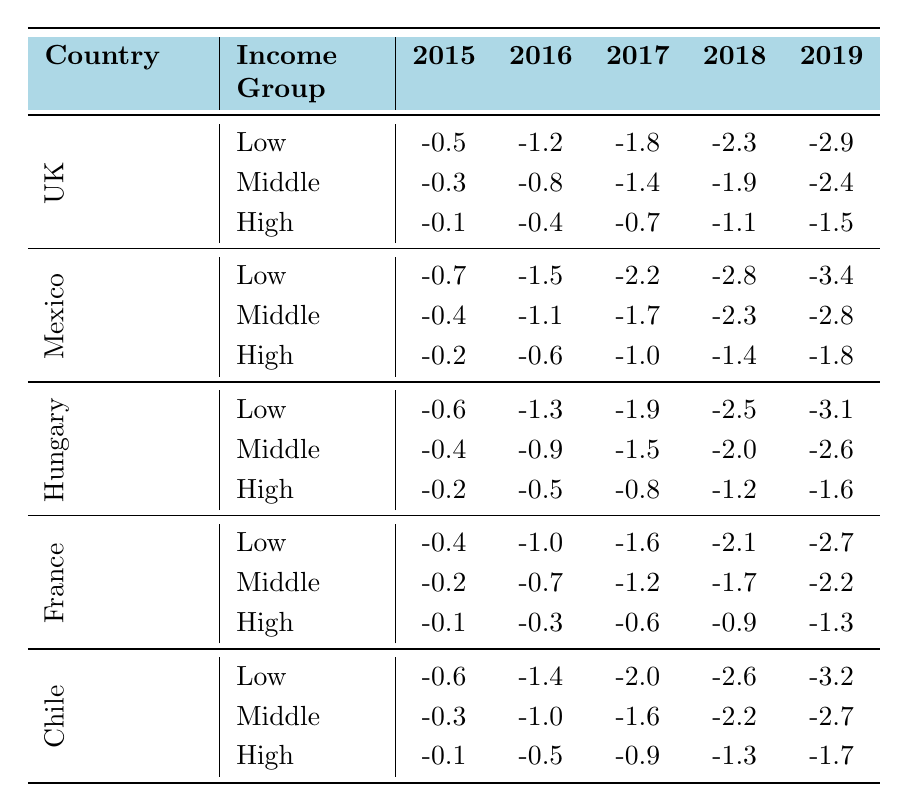What was the obesity rate change in the Low income group in Mexico in 2019? Referring to the table, the value for Mexico in the Low income group for 2019 is -3.4.
Answer: -3.4 Which income group in Hungary experienced the smallest reduction in obesity rates in 2016? In Hungary, the values for 2016 are -1.3 for Low income, -0.9 for Middle income, and -0.5 for High income. The smallest reduction is -0.5 in the High income group.
Answer: High income What is the average obesity rate change for the Middle income group across all countries in 2018? To find the average, we sum the values for the Middle income group in 2018: -1.9 (UK) + -2.3 (Mexico) + -2.0 (Hungary) + -1.7 (France) + -2.2 (Chile) = -10.1. There are 5 data points, so the average is -10.1 / 5 = -2.02.
Answer: -2.02 Did the Low income group in Chile have a better obesity rate change in 2019 compared to the Low income group in France? In Chile, the change in 2019 is -3.2, while in France it is -2.7. Since -3.2 is lower than -2.7, Chile had a better obesity rate change in 2019. Thus, the statement is true.
Answer: Yes What is the total reduction in obesity rates for High income groups from 2015 to 2019 in all countries? Summing the changes from 2015 to 2019 in the High income groups: UK (-1.5) + Mexico (-1.8) + Hungary (-1.6) + France (-1.3) + Chile (-1.7) results in -1.5 + -1.8 + -1.6 + -1.3 + -1.7 = -8.9. Therefore, the total reduction for High income groups is -8.9.
Answer: -8.9 Which country showed the largest obesity rate reduction in the Low income group by 2019? Comparing the values for the Low income group in 2019 across countries: UK (-2.9), Mexico (-3.4), Hungary (-3.1), France (-2.7), and Chile (-3.2). The largest reduction is -3.4 in Mexico.
Answer: Mexico How do the healthcare cost savings in France compare to those in the United Kingdom for 2019? In 2019, the healthcare cost savings in France is 42, while in the UK it is 73. Comparing these figures, the UK shows higher cost savings than France in 2019.
Answer: UK is higher What is the difference in average obesity rate changes between High income and Low income groups in Hungary from 2015 to 2019? For Low income in Hungary: average = (-0.6 - 1.3 - 1.9 - 2.5 - 3.1)/5 = -1.8. For High income: average = (-0.2 - 0.5 - 0.8 - 1.2 - 1.6)/5 = -0.66. The difference is -1.8 - (-0.66) = -1.14, meaning Low income had a greater reduction.
Answer: -1.14 Which income group in the United Kingdom lost the most weight over the given period? The reductions for 2015 to 2019 in the UK are: Low (-2.9), Middle (-2.4), High (-1.5). The Low income group had the largest reduction of -2.9 over the period.
Answer: Low income 